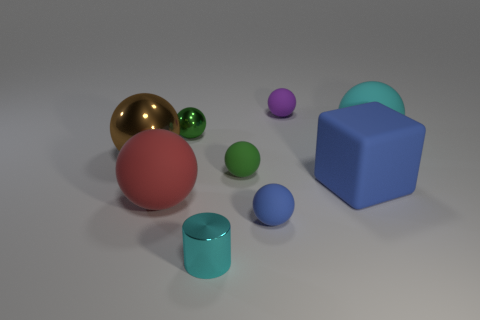Are there any other things that are the same shape as the small cyan object?
Offer a terse response. No. What is the shape of the purple object?
Keep it short and to the point. Sphere. There is a tiny matte sphere in front of the red sphere; what color is it?
Offer a very short reply. Blue. There is a green object that is in front of the brown metal thing; is it the same size as the tiny green shiny object?
Your answer should be compact. Yes. What size is the purple matte thing that is the same shape as the tiny blue rubber thing?
Your answer should be compact. Small. Does the green metallic thing have the same shape as the large brown object?
Provide a short and direct response. Yes. Are there fewer tiny rubber balls that are to the right of the cyan ball than green matte things on the right side of the tiny cyan shiny thing?
Offer a terse response. Yes. There is a big metallic thing; how many big cyan rubber spheres are in front of it?
Your response must be concise. 0. Do the small metallic object in front of the big cube and the blue matte thing in front of the big blue thing have the same shape?
Make the answer very short. No. How many other objects are there of the same color as the tiny shiny cylinder?
Make the answer very short. 1. 